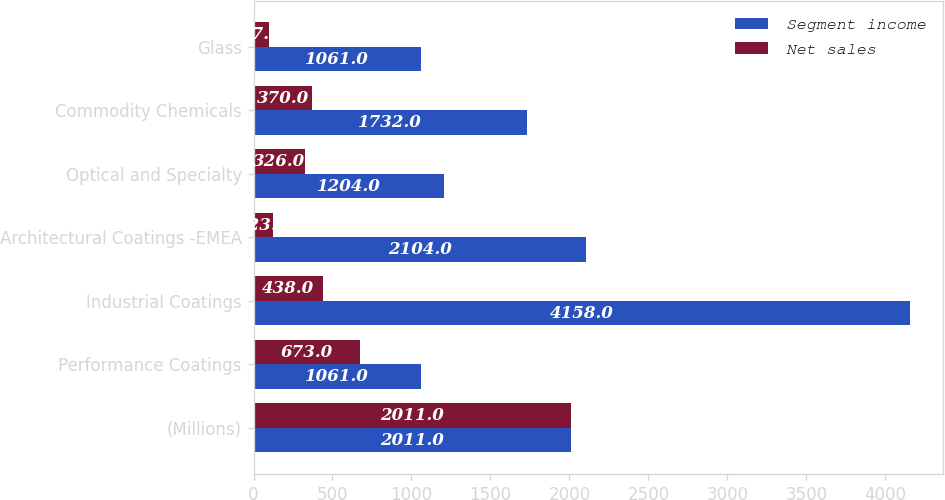Convert chart to OTSL. <chart><loc_0><loc_0><loc_500><loc_500><stacked_bar_chart><ecel><fcel>(Millions)<fcel>Performance Coatings<fcel>Industrial Coatings<fcel>Architectural Coatings -EMEA<fcel>Optical and Specialty<fcel>Commodity Chemicals<fcel>Glass<nl><fcel>Segment income<fcel>2011<fcel>1061<fcel>4158<fcel>2104<fcel>1204<fcel>1732<fcel>1061<nl><fcel>Net sales<fcel>2011<fcel>673<fcel>438<fcel>123<fcel>326<fcel>370<fcel>97<nl></chart> 